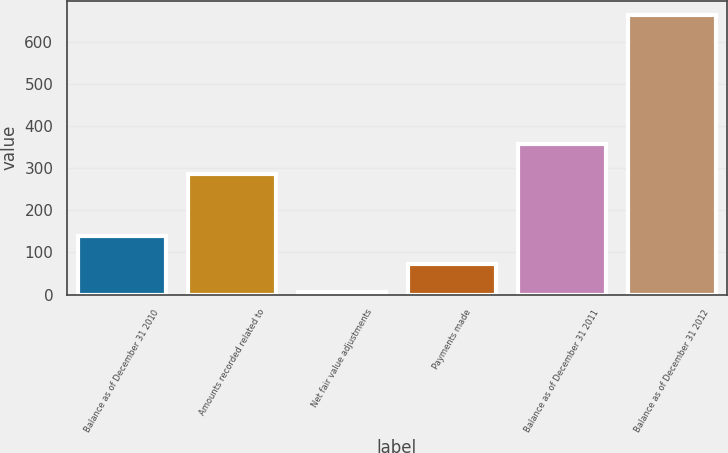Convert chart to OTSL. <chart><loc_0><loc_0><loc_500><loc_500><bar_chart><fcel>Balance as of December 31 2010<fcel>Amounts recorded related to<fcel>Net fair value adjustments<fcel>Payments made<fcel>Balance as of December 31 2011<fcel>Balance as of December 31 2012<nl><fcel>138.2<fcel>287<fcel>7<fcel>72.6<fcel>358<fcel>663<nl></chart> 